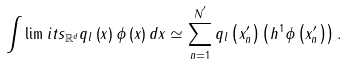Convert formula to latex. <formula><loc_0><loc_0><loc_500><loc_500>\int \lim i t s _ { \mathbb { R } ^ { d } } q _ { l } \left ( x \right ) \phi \left ( x \right ) d x \simeq \sum _ { n = 1 } ^ { N ^ { ^ { \prime } } } q _ { l } \left ( x _ { n } ^ { \prime } \right ) \left ( h ^ { 1 } \phi \left ( x _ { n } ^ { \prime } \right ) \right ) .</formula> 